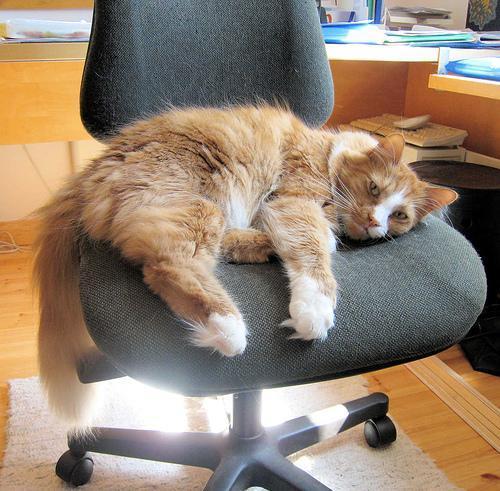How many blue folders are resting up on their ends?
Give a very brief answer. 2. 